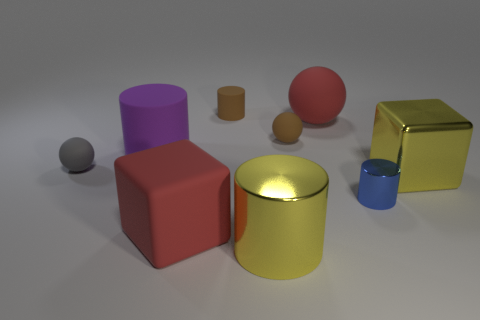How would you describe the ambient light in the room and how it affects the objects? The ambient light appears soft and diffused, creating gentle shadows and subtle highlights on the objects, which suggests an evenly lit environment. This diffuse lighting minimizes harsh contrasts and allows the inherent colors and materials of the objects to be visible without strong reflections or deep shadows. 